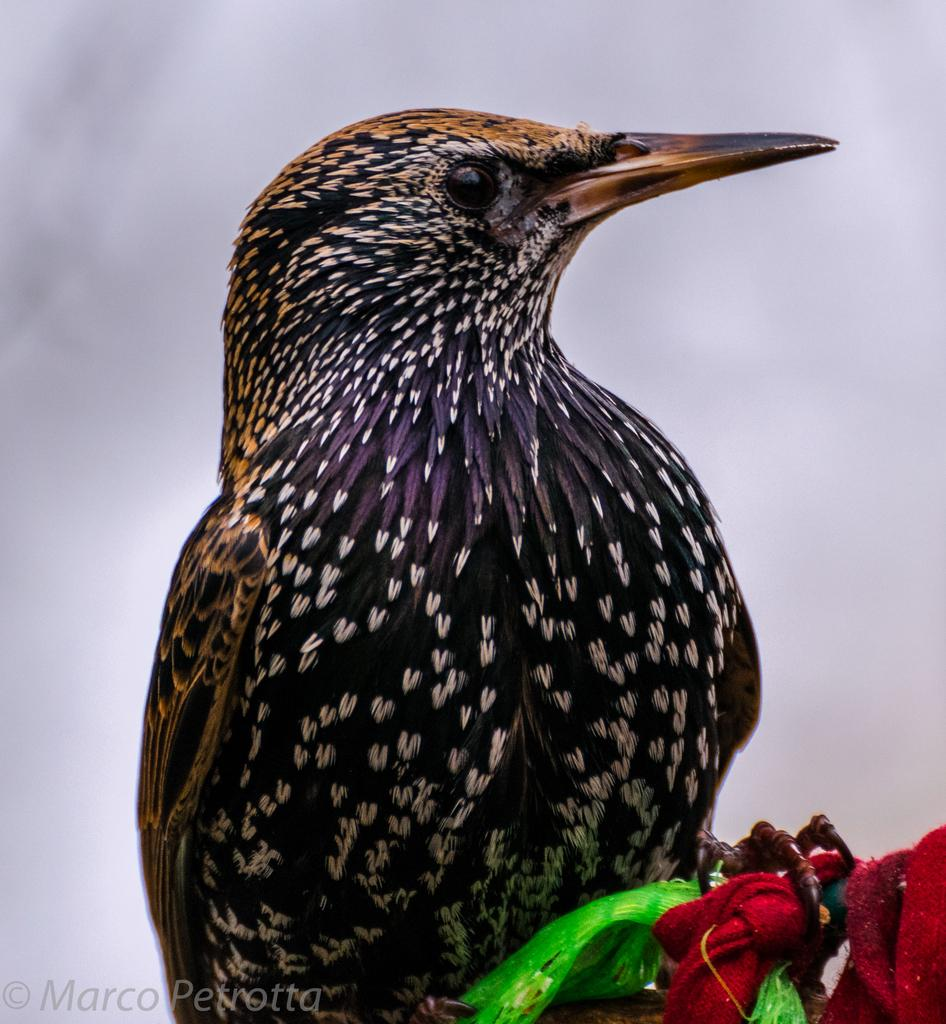What type of animal is in the image? There is a bird in the image. Where is the bird located in the image? The bird is in the front of the image. What can be seen at the right bottom of the image? There are ribbons at the right bottom of the image. What is visible in the background of the image? The sky is visible in the background of the image. What is present at the left bottom of the image? There is some text at the left bottom of the image. What type of copper object can be seen near the bird in the image? There is no copper object present in the image. How many geese are swimming in the river in the image? There is no river or geese present in the image. 